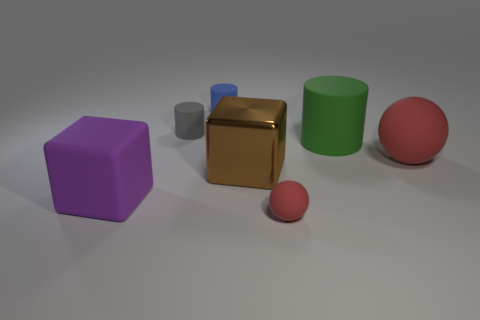Add 2 large yellow matte spheres. How many objects exist? 9 Subtract all cylinders. How many objects are left? 4 Add 3 large rubber balls. How many large rubber balls exist? 4 Subtract 0 blue spheres. How many objects are left? 7 Subtract all big blue balls. Subtract all small cylinders. How many objects are left? 5 Add 7 brown objects. How many brown objects are left? 8 